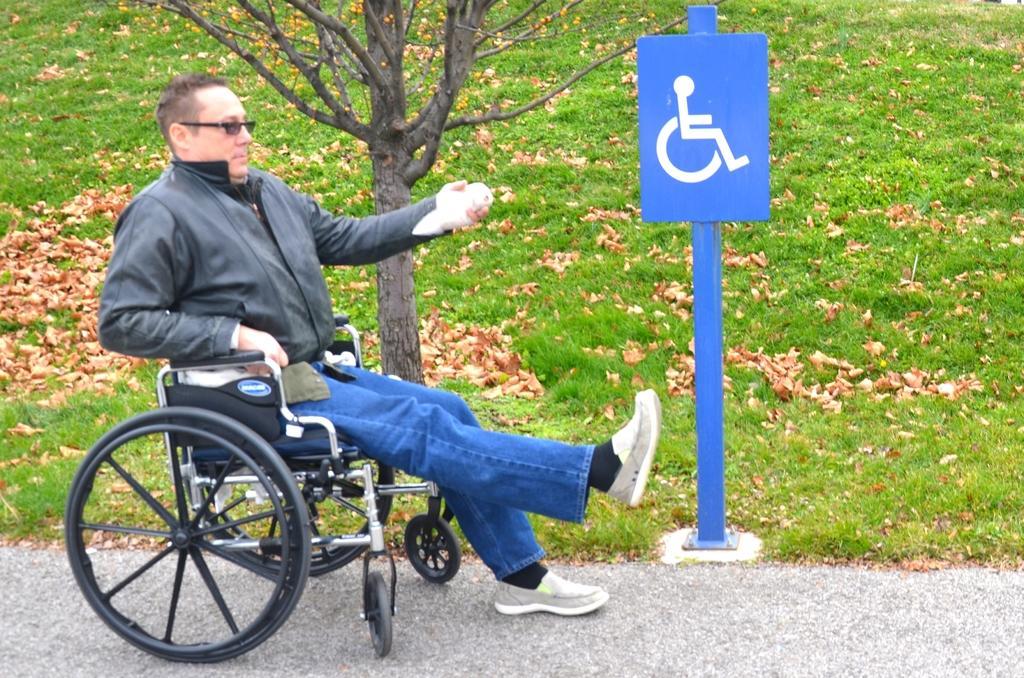In one or two sentences, can you explain what this image depicts? In this image we can see a person sitting on the wheel chair, there is a pole, on the pole, we can see a board, there are some leaves and grass on the ground, also we can see a tree. 